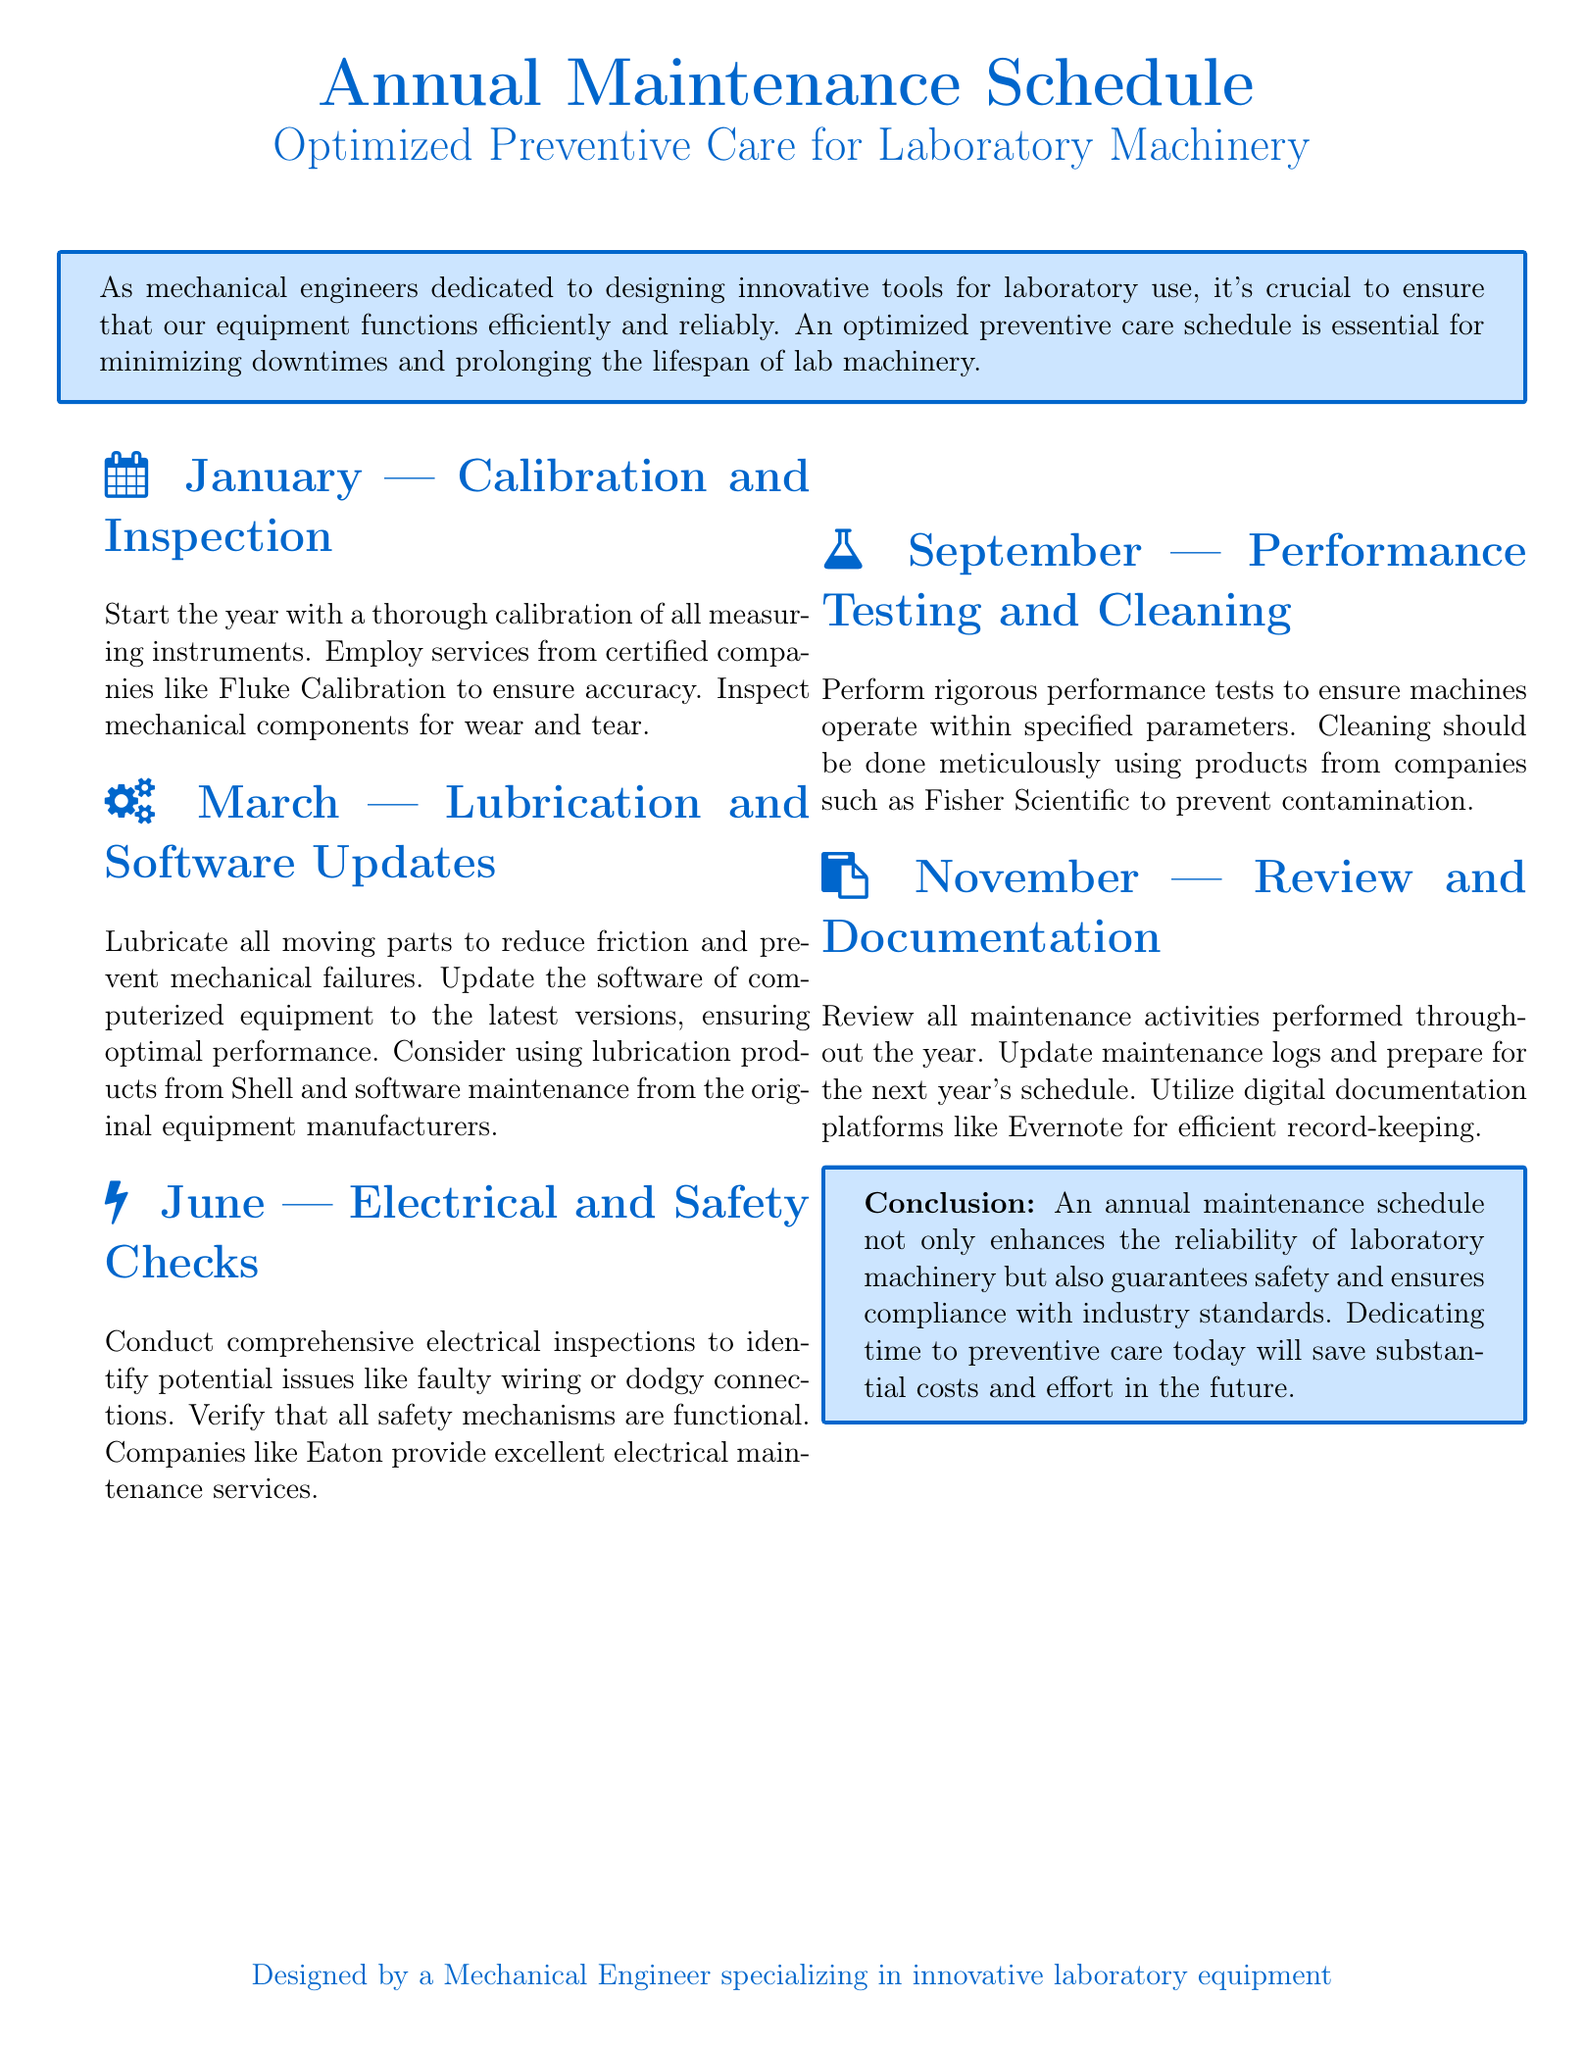What is the focus of the document? The document emphasizes the importance of an optimized preventive care schedule for laboratory machinery.
Answer: Optimized Preventive Care for Laboratory Machinery In which month is calibration and inspection scheduled? The document specifies January for calibration and inspection activities.
Answer: January Which company's products are recommended for lubrication? The document suggests using lubrication products from Shell.
Answer: Shell What is checked in June as per the maintenance schedule? The document states that comprehensive electrical inspections and safety checks are conducted in June.
Answer: Electrical and Safety Checks What software maintenance action is highlighted in March? The document mentions updating the software of computerized equipment to the latest versions in March.
Answer: Software Updates Why is performance testing conducted in September? The document indicates that rigorous performance tests are performed to ensure machines operate within specified parameters.
Answer: To ensure machines operate within specified parameters What platform is suggested for maintaining documentation? The document recommends using digital documentation platforms like Evernote for efficient record-keeping.
Answer: Evernote What aspect of maintenance is reviewed in November? The document specifies that all maintenance activities performed throughout the year are reviewed in November.
Answer: Maintenance activities What type of maintenance is emphasized in the conclusion? The document concludes by emphasizing the enhancement of reliability through the annual maintenance schedule.
Answer: Reliability of laboratory machinery 